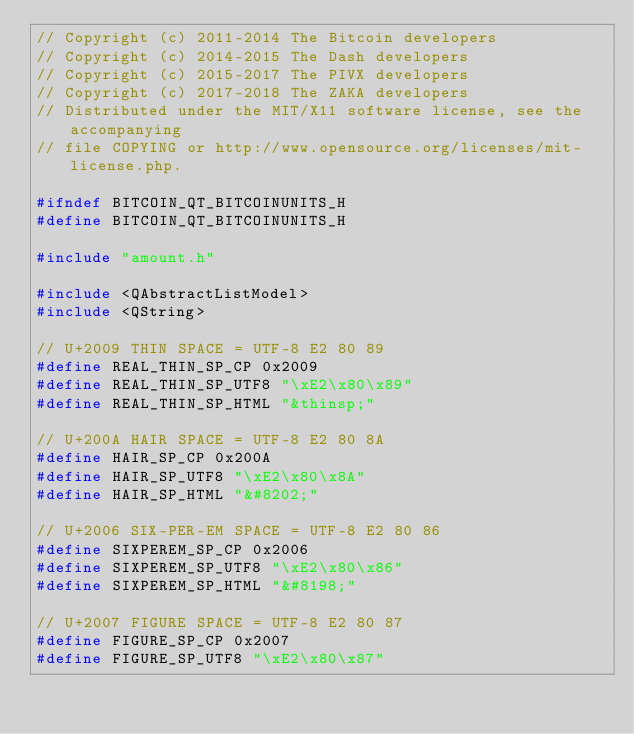<code> <loc_0><loc_0><loc_500><loc_500><_C_>// Copyright (c) 2011-2014 The Bitcoin developers
// Copyright (c) 2014-2015 The Dash developers
// Copyright (c) 2015-2017 The PIVX developers
// Copyright (c) 2017-2018 The ZAKA developers
// Distributed under the MIT/X11 software license, see the accompanying
// file COPYING or http://www.opensource.org/licenses/mit-license.php.

#ifndef BITCOIN_QT_BITCOINUNITS_H
#define BITCOIN_QT_BITCOINUNITS_H

#include "amount.h"

#include <QAbstractListModel>
#include <QString>

// U+2009 THIN SPACE = UTF-8 E2 80 89
#define REAL_THIN_SP_CP 0x2009
#define REAL_THIN_SP_UTF8 "\xE2\x80\x89"
#define REAL_THIN_SP_HTML "&thinsp;"

// U+200A HAIR SPACE = UTF-8 E2 80 8A
#define HAIR_SP_CP 0x200A
#define HAIR_SP_UTF8 "\xE2\x80\x8A"
#define HAIR_SP_HTML "&#8202;"

// U+2006 SIX-PER-EM SPACE = UTF-8 E2 80 86
#define SIXPEREM_SP_CP 0x2006
#define SIXPEREM_SP_UTF8 "\xE2\x80\x86"
#define SIXPEREM_SP_HTML "&#8198;"

// U+2007 FIGURE SPACE = UTF-8 E2 80 87
#define FIGURE_SP_CP 0x2007
#define FIGURE_SP_UTF8 "\xE2\x80\x87"</code> 